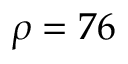Convert formula to latex. <formula><loc_0><loc_0><loc_500><loc_500>\rho = 7 6</formula> 